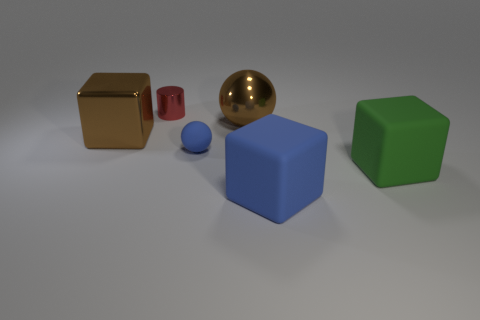There is a tiny blue rubber sphere; are there any tiny blue spheres in front of it?
Provide a succinct answer. No. Do the brown sphere and the green rubber cube have the same size?
Keep it short and to the point. Yes. What material is the tiny thing that is in front of the small red cylinder behind the brown metallic sphere made of?
Ensure brevity in your answer.  Rubber. Do the big green rubber object and the tiny blue rubber thing have the same shape?
Your answer should be compact. No. How many objects are to the left of the big brown metal sphere and right of the big metal cube?
Give a very brief answer. 2. Are there an equal number of big metallic things left of the blue block and blue spheres that are to the right of the large green matte block?
Keep it short and to the point. No. There is a blue rubber ball to the right of the tiny shiny object; does it have the same size as the red shiny cylinder that is behind the big metallic block?
Keep it short and to the point. Yes. The large thing that is right of the metallic block and behind the big green thing is made of what material?
Offer a very short reply. Metal. Are there fewer brown objects than blocks?
Offer a terse response. Yes. There is a shiny thing behind the brown object right of the large metallic block; what is its size?
Give a very brief answer. Small. 